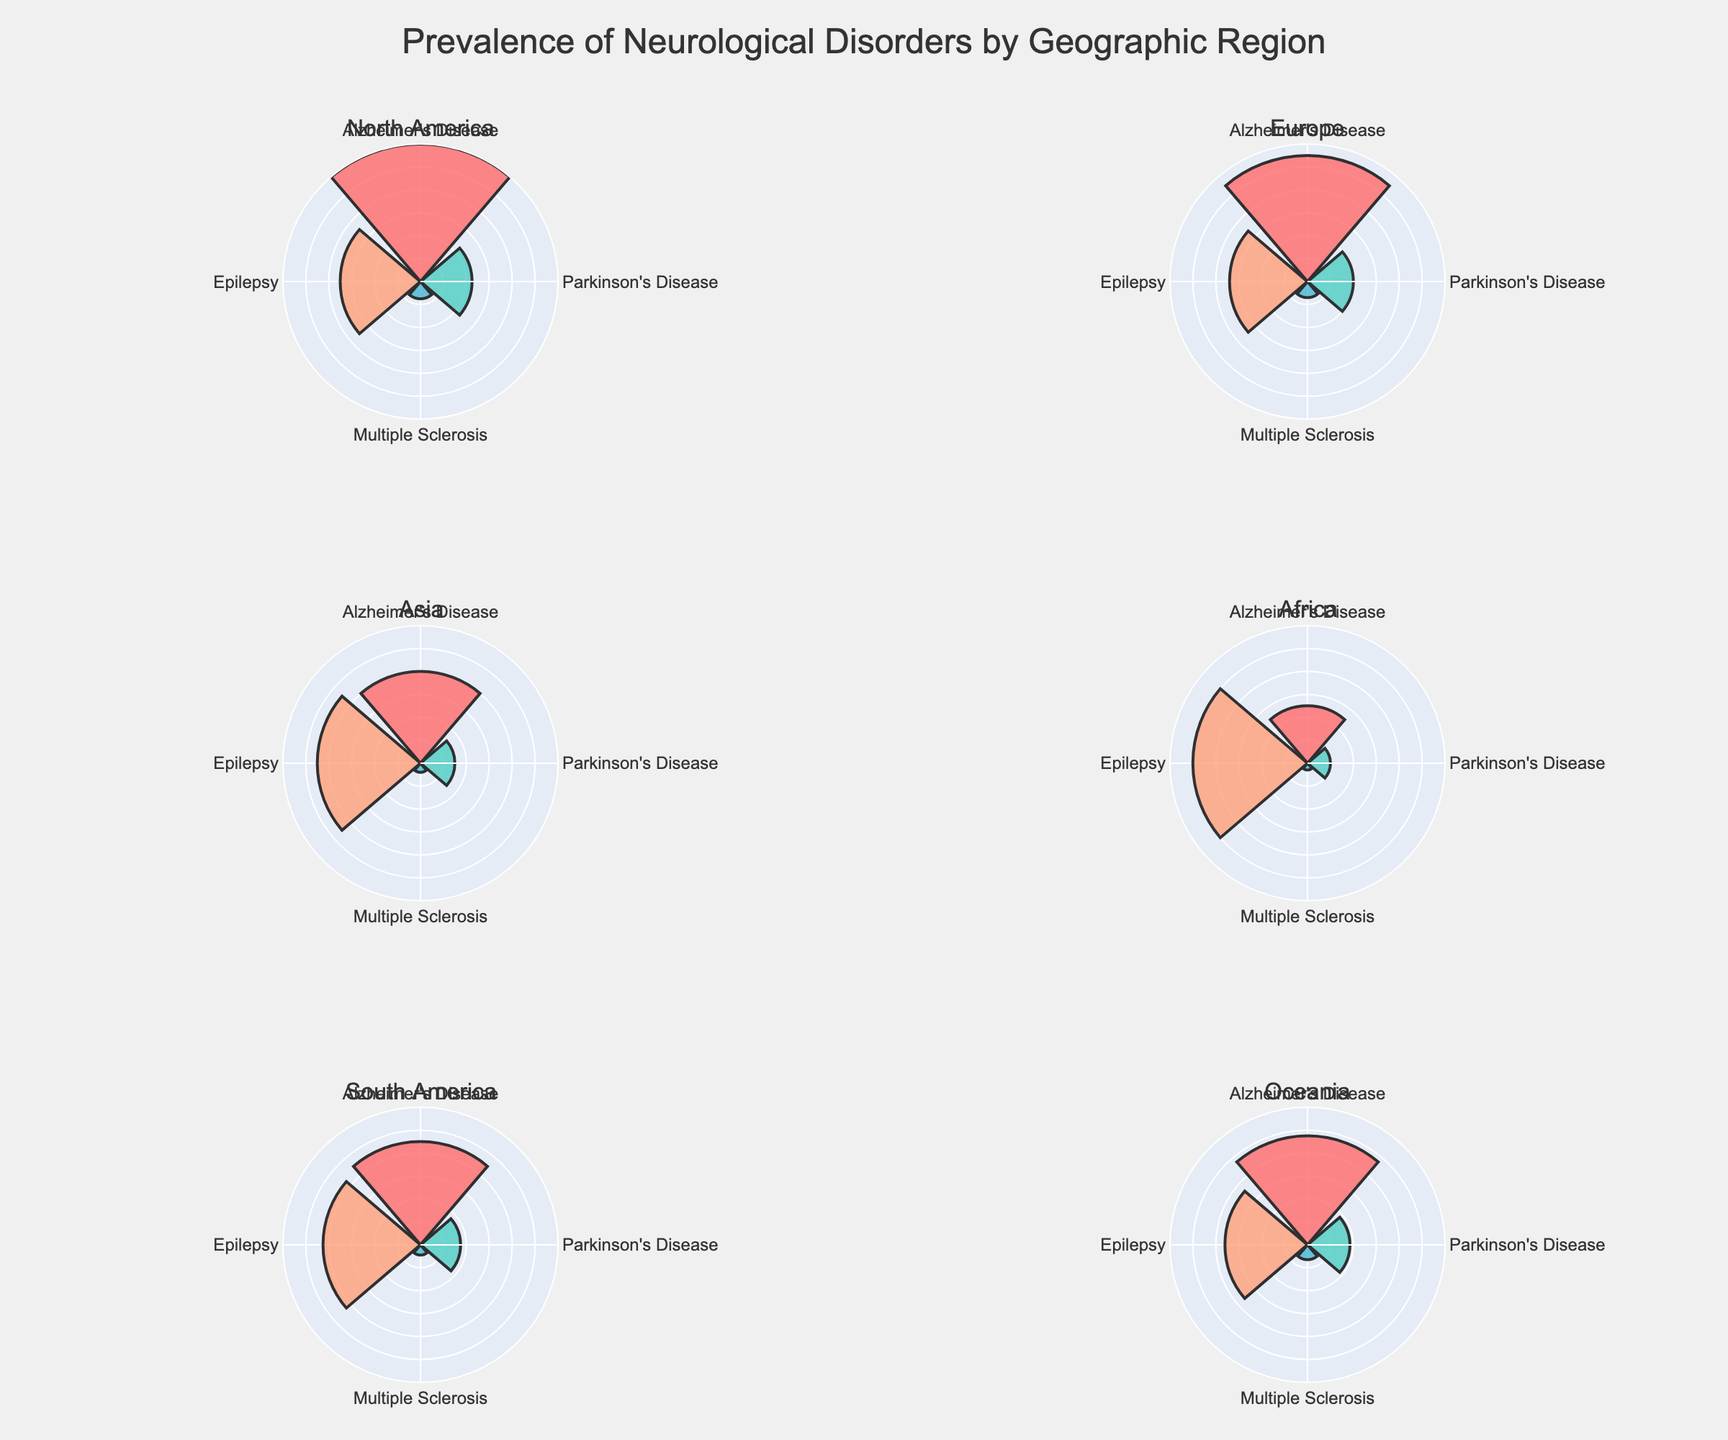What is the title of the plot? The title is located at the top center of the figure. It is "Prevalence of Neurological Disorders by Geographic Region".
Answer: Prevalence of Neurological Disorders by Geographic Region Which region has the highest prevalence of Epilepsy? By comparing the length of the bars representing Epilepsy across all regions' subplots, Africa has the tallest bar for Epilepsy.
Answer: Africa What is the color used to represent Multiple Sclerosis across all regions? The color for Multiple Sclerosis can be identified by looking at the legend or referring to the bars labeled as Multiple Sclerosis in various subplots, which is the third color from left to right.
Answer: #45B7D1 Which disorder has the smallest prevalence in Asia? In the Asia subplot, the shortest bar indicates the disorder with the smallest prevalence, which is Multiple Sclerosis.
Answer: Multiple Sclerosis Compare the prevalence of Parkinson's Disease and Multiple Sclerosis in North America. Which one is higher and by how much? In the North America subplot, compare the bars for Parkinson's Disease and Multiple Sclerosis. Parkinson's Disease has a prevalence of 450 and Multiple Sclerosis has a prevalence of 150. The difference is 450 - 150 = 300.
Answer: Parkinson's Disease by 300 Calculate the average prevalence of Alzheimer's Disease across all regions. Add up the prevalence values of Alzheimer's Disease in all regions (1200 + 1100 + 800 + 500 + 900 + 950) and divide by the number of regions (6). The calculation is (1200 + 1100 + 800 + 500 + 900 + 950) / 6 = 7450 / 6 ~ 1241.67.
Answer: ~1241.67 What is the overall trend for the prevalence of Epilepsy compared to other disorders? Observing all subplots, Epilepsy generally has higher prevalence values compared to the other disorders in most regions, indicating it is a more common neurological disorder on a broader scale.
Answer: Higher overall Which regions show a prevalence of Alzheimer's Disease greater than 1000 per 100,000? By examining each subplot's Alzheimer's Disease bar, North America (1200), Europe (1100), South America (900), and Oceania (950) all have Alzheimer's Disease prevalence greater than 1000.
Answer: North America, Europe Identify the region with the smallest prevalence for Parkinson's Disease and provide the value. Comparing the Parkinson's Disease bars in each subplot, Africa has the smallest value, which is 200 per 100,000.
Answer: Africa with 200 